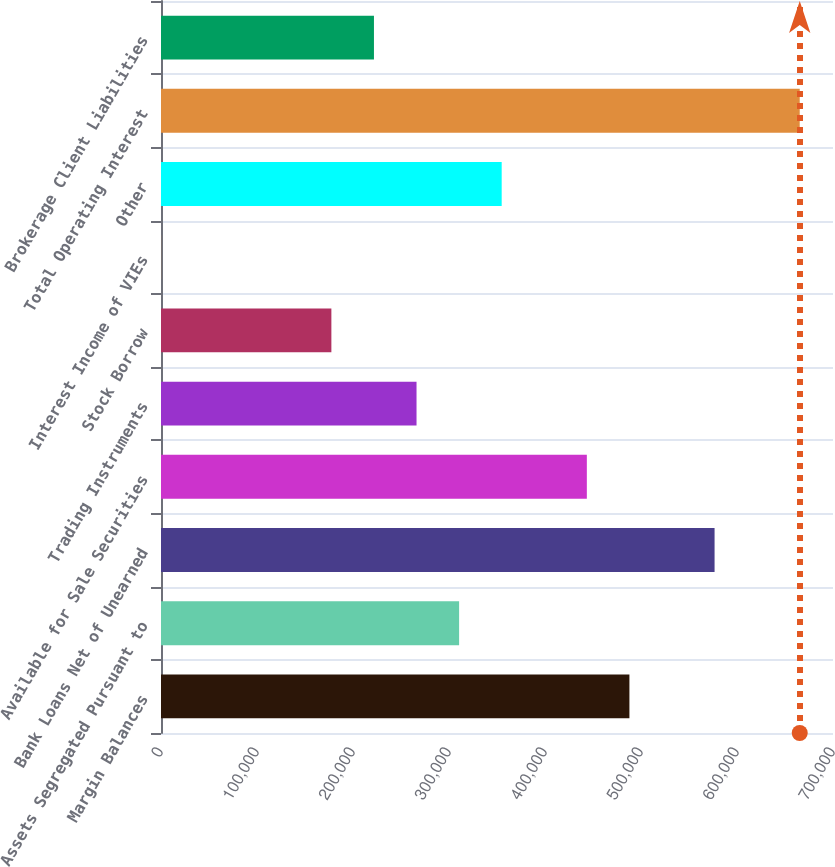<chart> <loc_0><loc_0><loc_500><loc_500><bar_chart><fcel>Margin Balances<fcel>Assets Segregated Pursuant to<fcel>Bank Loans Net of Unearned<fcel>Available for Sale Securities<fcel>Trading Instruments<fcel>Stock Borrow<fcel>Interest Income of VIEs<fcel>Other<fcel>Total Operating Interest<fcel>Brokerage Client Liabilities<nl><fcel>487935<fcel>310530<fcel>576638<fcel>443584<fcel>266179<fcel>177476<fcel>71<fcel>354881<fcel>665340<fcel>221828<nl></chart> 